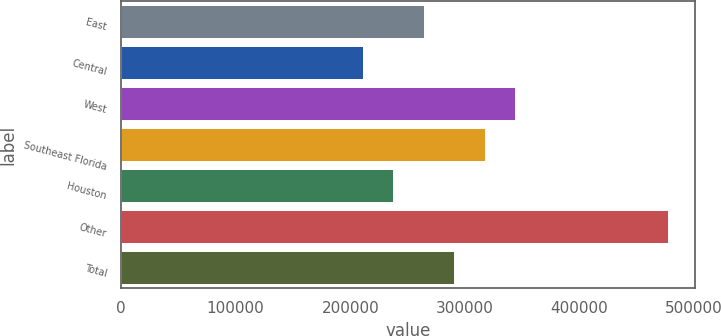Convert chart. <chart><loc_0><loc_0><loc_500><loc_500><bar_chart><fcel>East<fcel>Central<fcel>West<fcel>Southeast Florida<fcel>Houston<fcel>Other<fcel>Total<nl><fcel>264200<fcel>211000<fcel>344000<fcel>317400<fcel>237600<fcel>477000<fcel>290800<nl></chart> 